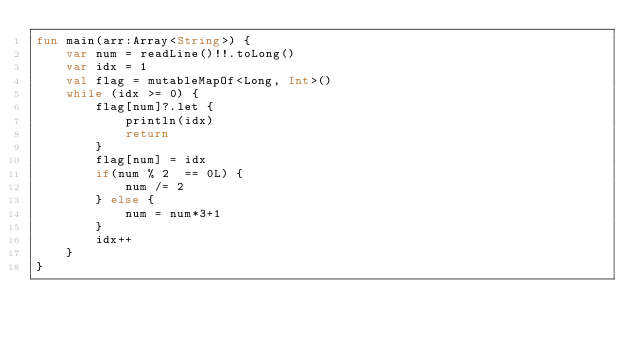Convert code to text. <code><loc_0><loc_0><loc_500><loc_500><_Kotlin_>fun main(arr:Array<String>) {
    var num = readLine()!!.toLong()
    var idx = 1
    val flag = mutableMapOf<Long, Int>()
    while (idx >= 0) {
        flag[num]?.let {
            println(idx)
            return
        }
        flag[num] = idx
        if(num % 2  == 0L) {
            num /= 2
        } else {
            num = num*3+1
        }
        idx++
    }
}
</code> 